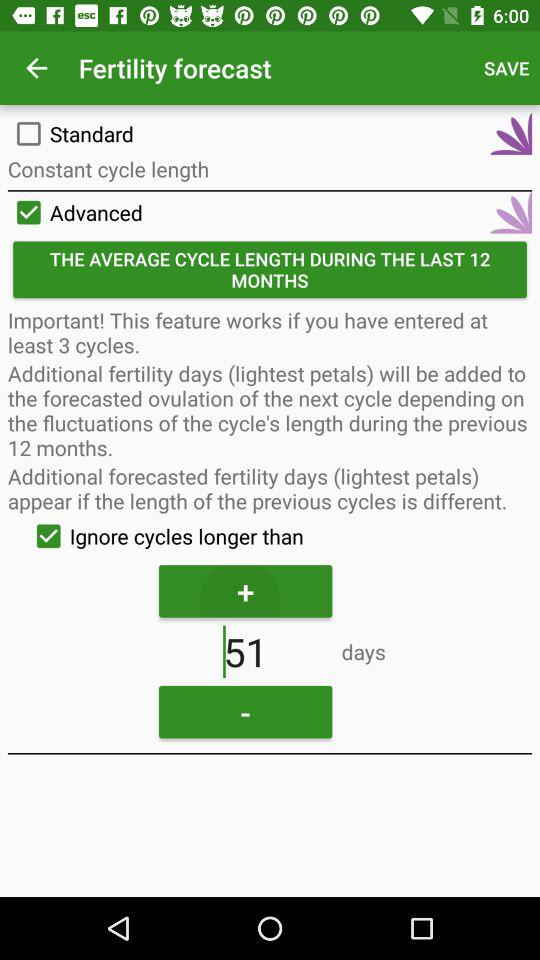How many days are shown? The shown days are 51. 